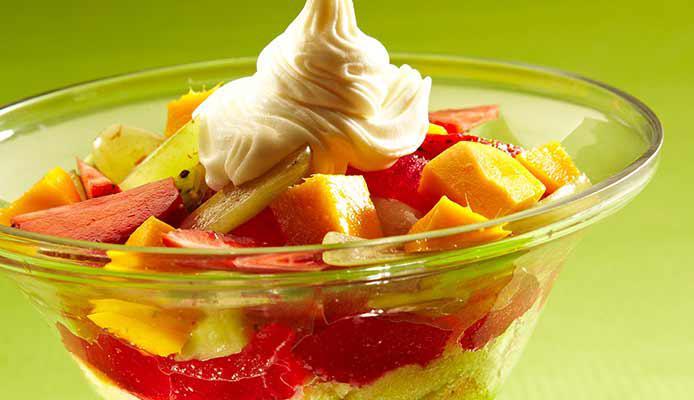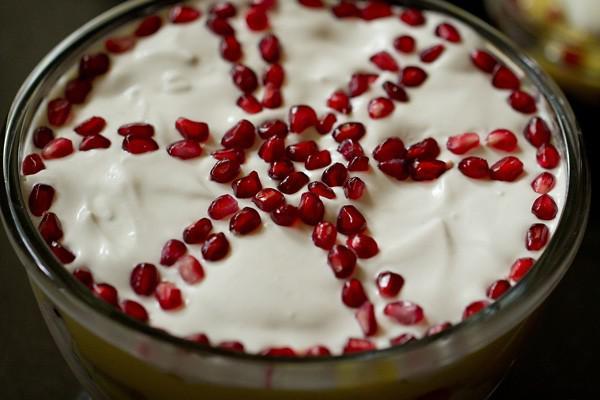The first image is the image on the left, the second image is the image on the right. For the images shown, is this caption "A trifle is garnished with pomegranite seeds arranged in a spoke pattern." true? Answer yes or no. Yes. 